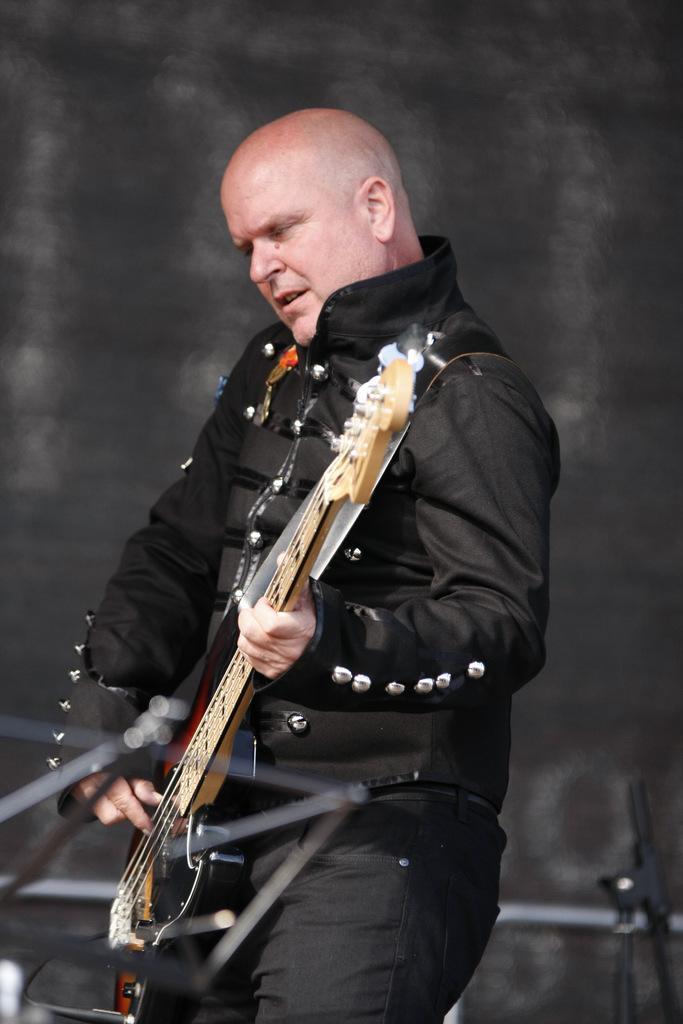Please provide a concise description of this image. In this picture there is a man playing guitar. He is wearing a shiny black jacket. In front of him there is a book holder. To the right corner of the image there is a microphone stand. In the background there is wall. 